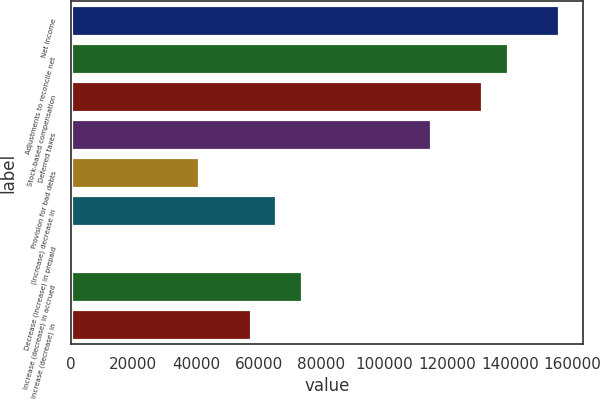Convert chart. <chart><loc_0><loc_0><loc_500><loc_500><bar_chart><fcel>Net income<fcel>Adjustments to reconcile net<fcel>Stock-based compensation<fcel>Deferred taxes<fcel>Provision for bad debts<fcel>(Increase) decrease in<fcel>Decrease (increase) in prepaid<fcel>Increase (decrease) in accrued<fcel>Increase (decrease) in<nl><fcel>155727<fcel>139343<fcel>131151<fcel>114768<fcel>41040.5<fcel>65616.2<fcel>81<fcel>73808.1<fcel>57424.3<nl></chart> 